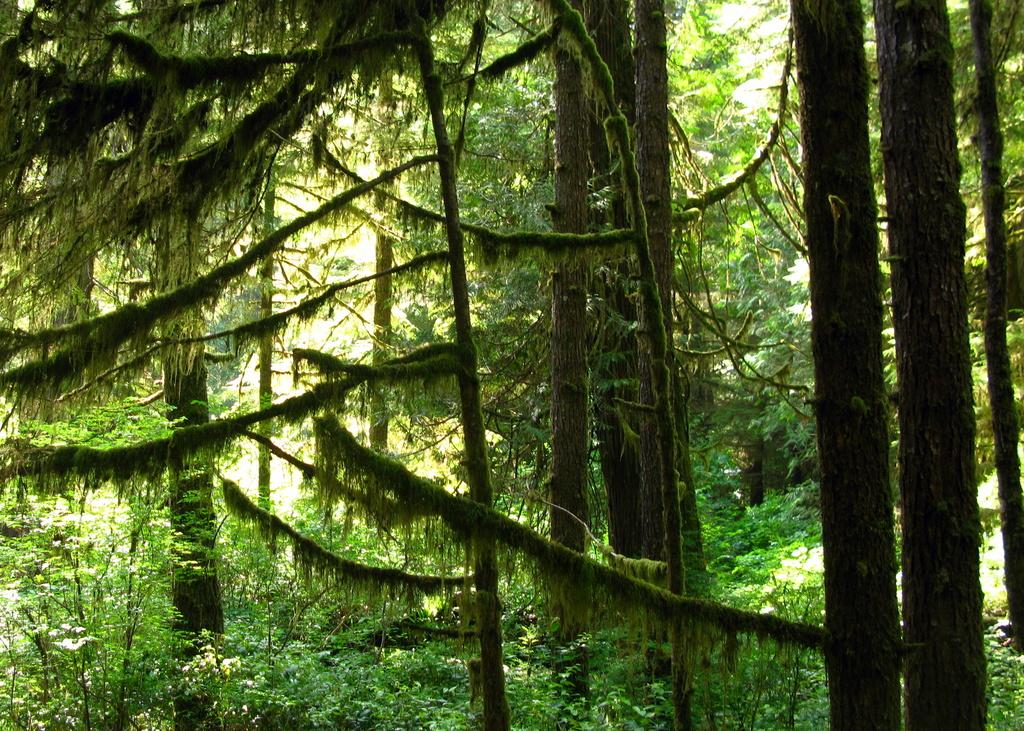What type of vegetation can be seen in the image? There are plants and trees in the image. What part of the natural environment is visible in the image? The sky is visible in the image. Can the image have been taken in a forest? Yes, the image may have been taken in a forest, given the presence of plants and trees. What time of day might the image have been taken? The image may have been taken during the day, as the sky is visible. What type of pest can be seen crawling on the leaves in the image? There is no pest visible on the leaves in the image. What type of blade is being used to cut the trees in the image? There is no blade or tree-cutting activity visible in the image. 